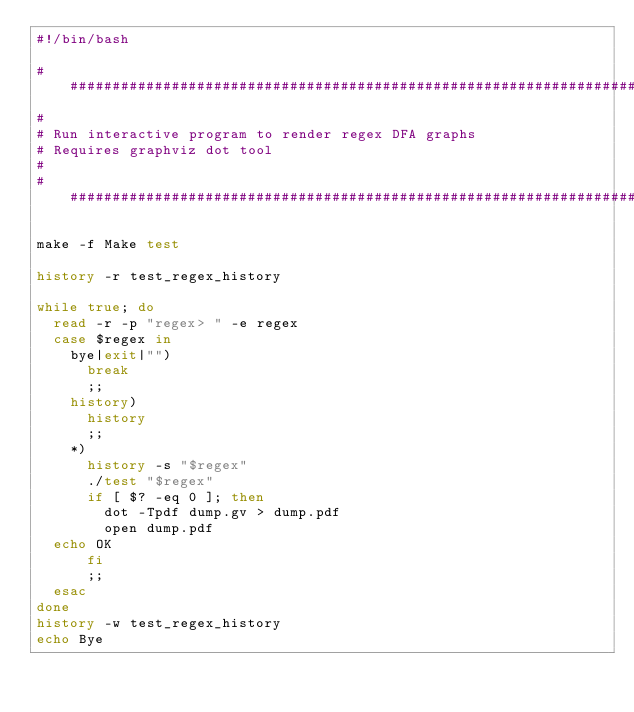Convert code to text. <code><loc_0><loc_0><loc_500><loc_500><_Bash_>#!/bin/bash

################################################################################
#
#	Run interactive program to render regex DFA graphs
#	Requires graphviz dot tool
#
################################################################################

make -f Make test

history -r test_regex_history

while true; do
  read -r -p "regex> " -e regex
  case $regex in
    bye|exit|"")
      break
      ;;
    history)
      history
      ;;
    *)
      history -s "$regex"
      ./test "$regex"
      if [ $? -eq 0 ]; then
        dot -Tpdf dump.gv > dump.pdf
        open dump.pdf
	echo OK
      fi
      ;;
  esac
done
history -w test_regex_history
echo Bye
</code> 